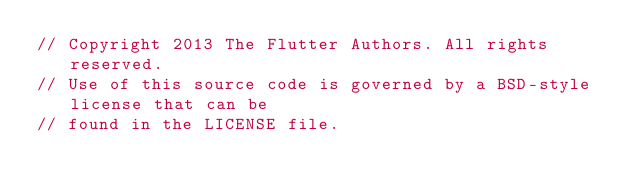Convert code to text. <code><loc_0><loc_0><loc_500><loc_500><_ObjectiveC_>// Copyright 2013 The Flutter Authors. All rights reserved.
// Use of this source code is governed by a BSD-style license that can be
// found in the LICENSE file.
</code> 